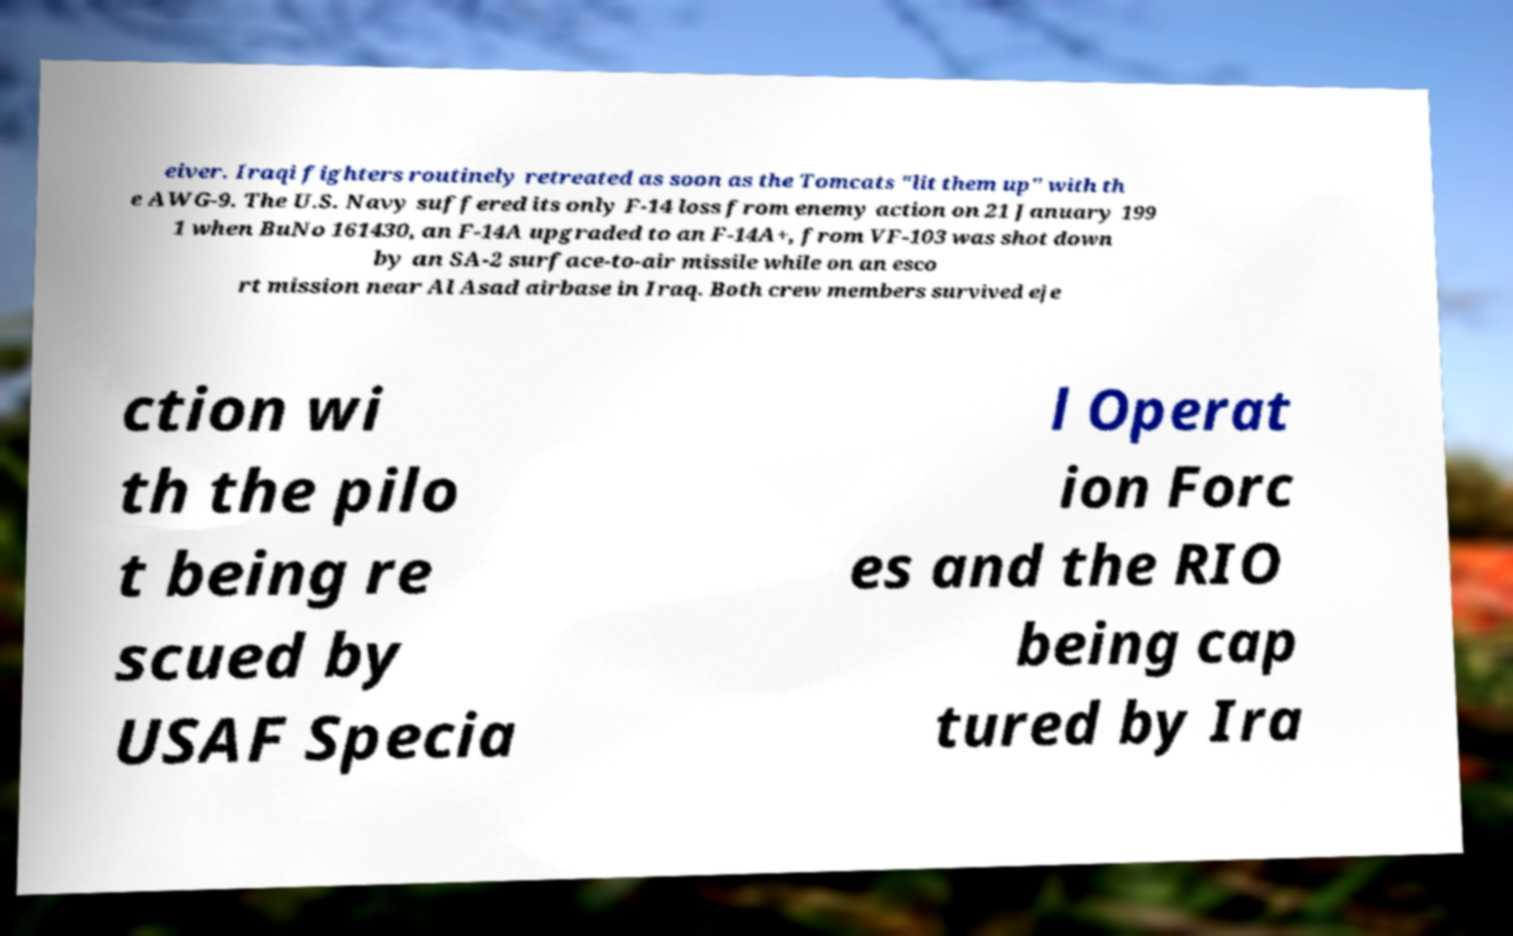Can you read and provide the text displayed in the image?This photo seems to have some interesting text. Can you extract and type it out for me? eiver. Iraqi fighters routinely retreated as soon as the Tomcats "lit them up" with th e AWG-9. The U.S. Navy suffered its only F-14 loss from enemy action on 21 January 199 1 when BuNo 161430, an F-14A upgraded to an F-14A+, from VF-103 was shot down by an SA-2 surface-to-air missile while on an esco rt mission near Al Asad airbase in Iraq. Both crew members survived eje ction wi th the pilo t being re scued by USAF Specia l Operat ion Forc es and the RIO being cap tured by Ira 